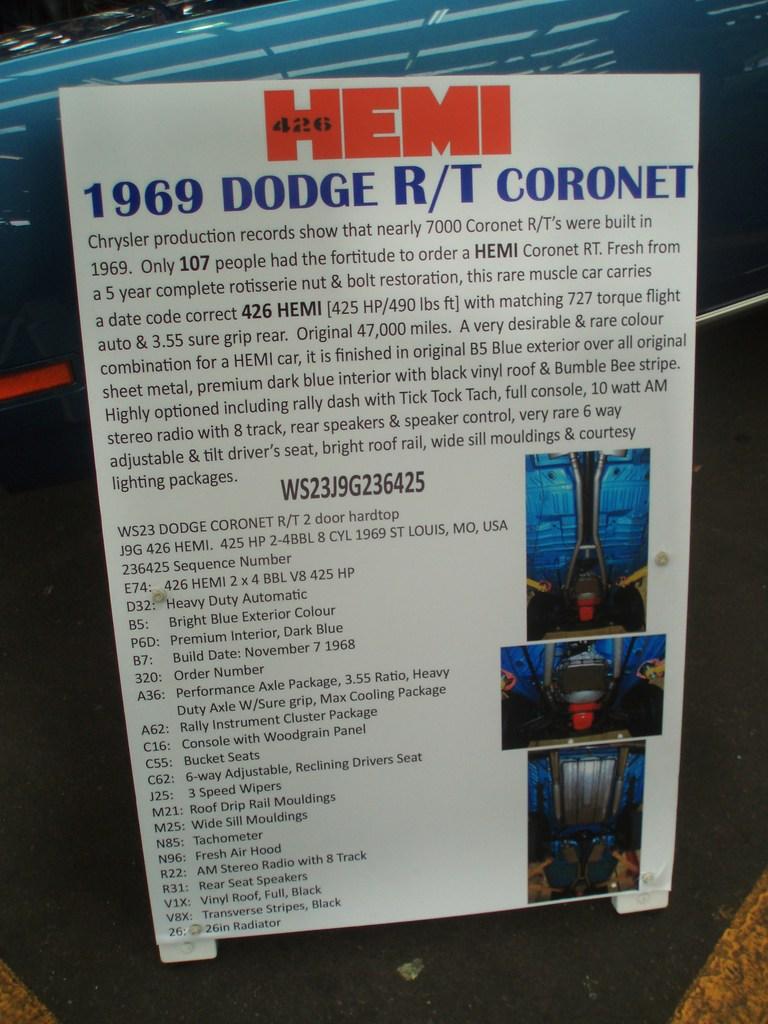What year is that dodge?
Ensure brevity in your answer.  1969. What year was this car made?
Your answer should be very brief. 1969. 